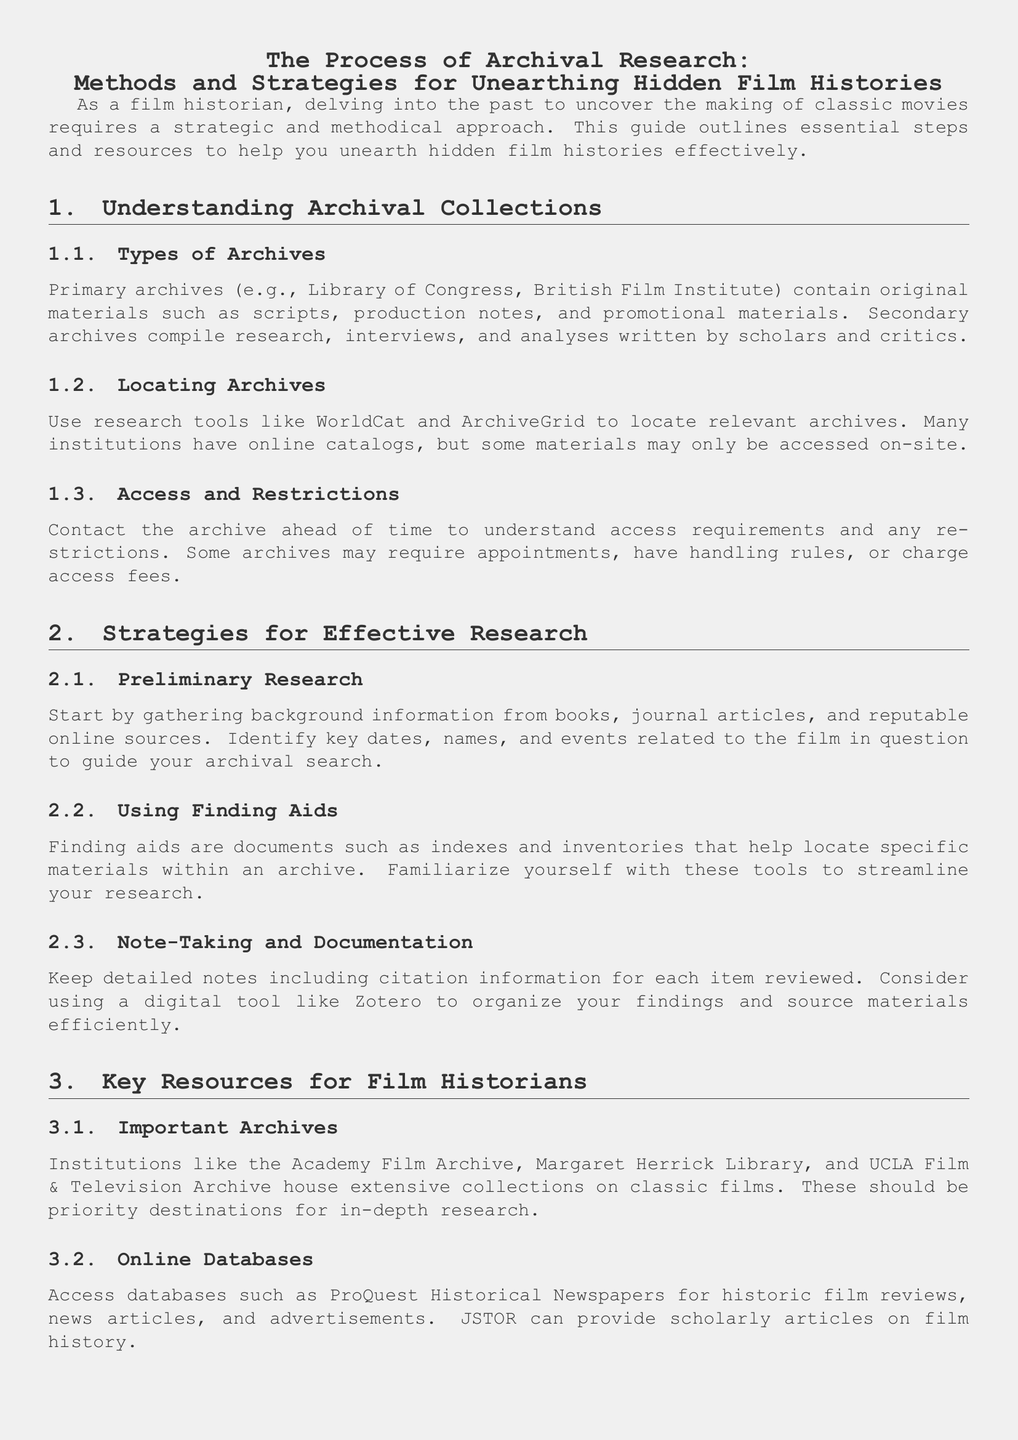What are primary archives? Primary archives contain original materials such as scripts, production notes, and promotional materials related to classic movies.
Answer: Original materials What is a recommended tool for locating archives? WorldCat and ArchiveGrid are suggested research tools for finding relevant archives.
Answer: WorldCat What should you do before visiting an archive? It's advisable to contact the archive ahead of time to understand access requirements and any restrictions.
Answer: Contact the archive What does preliminary research involve? Gathering background information from books, journal articles, and reputable online sources is essential for effective preliminary research.
Answer: Gathering background information Name one important archive for film historians. The Academy Film Archive is one of the important archives housing extensive collections on classic films.
Answer: Academy Film Archive What is the role of finding aids in archival research? Finding aids help researchers locate specific materials within an archive, making the research process more efficient.
Answer: Locate specific materials Which online database can provide historic film reviews? ProQuest Historical Newspapers offers access to historic film reviews, news articles, and advertisements.
Answer: ProQuest Historical Newspapers What do expert networks provide for film historians? Engaging with expert networks provides opportunities for collaboration and insights through conferences and seminars.
Answer: Collaboration and insights 